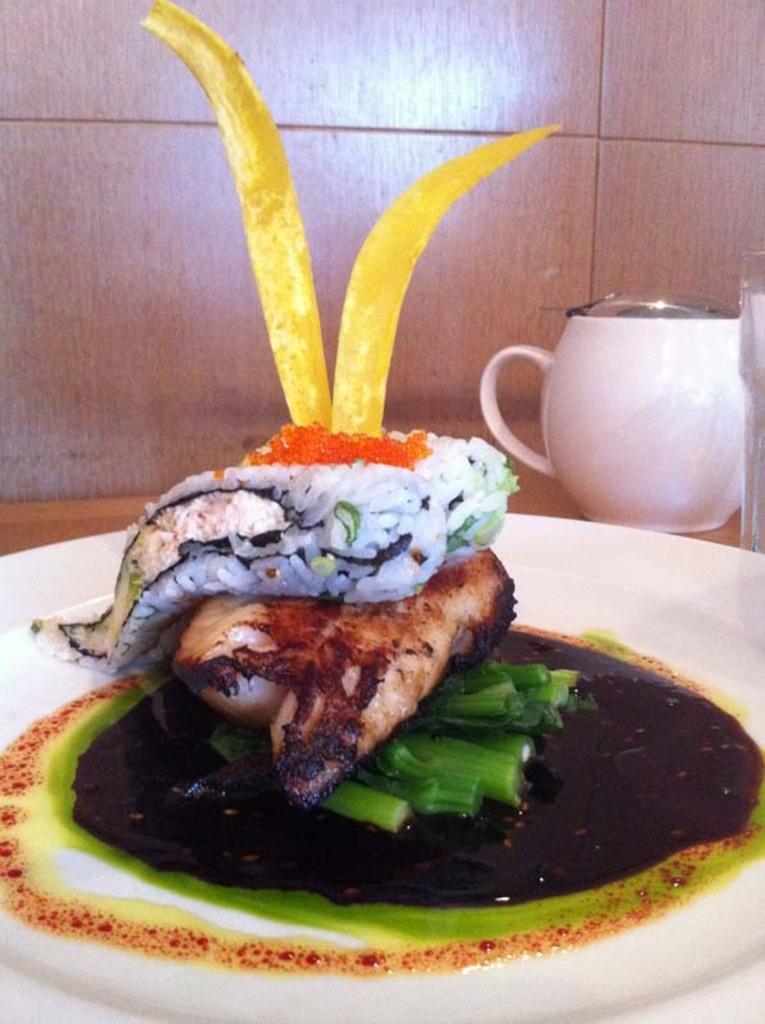How would you summarize this image in a sentence or two? In this image we can see some food in a plate which is placed on the surface. We can also see a jar and a glass beside it. On the backside we can see a wall. 